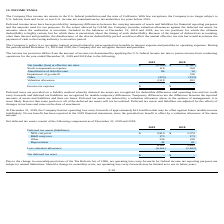According to Sunworks's financial document, What is the net operating loss carry-forwards at December 31, 2019? According to the financial document, $21.6 million. The relevant text states: "net operating loss carry-forwards of approximately $21.6 million that may be offset against future taxable income indefinitely. No tax benefit has been reported in t..." Also, What is the  NOL carryover for 2019? According to the financial document, $5,910. The relevant text states: "NOL carryover $ 5,910 $ 3,370..." Also, How are deferred tax assets and liabilities adjusted? adjusted for the effects of changes in tax laws and rates on the date of enactment. The document states: "realized. Deferred tax assets and liabilities are adjusted for the effects of changes in tax laws and rates on the date of enactment. At December 31, ..." Also, can you calculate: What is the percentage change in the total deferred tax assets from 2018 to 2019? To answer this question, I need to perform calculations using the financial data. The calculation is: (6,361-3,843)/3,843, which equals 65.52 (percentage). This is based on the information: "6,361 3,843 6,361 3,843..." The key data points involved are: 3,843, 6,361. Also, can you calculate: What is the percentage of R&D carryover in the total deferred tax assets in 2019? Based on the calculation: 173/6,361, the result is 2.72 (percentage). This is based on the information: "6,361 3,843 R&D carryover 173 173..." The key data points involved are: 173, 6,361. Also, can you calculate: What is the percentage of depreciation in the total deferred tax assets in 2018? Based on the calculation: 61/3,843, the result is 1.59 (percentage). This is based on the information: "6,361 3,843 6,361 3,843..." The key data points involved are: 3,843, 61. Additionally, In which year is the NOL carryover higher? According to the financial document, 2019. The relevant text states: "certain. Included in the balances at December 31, 2019 and 2018, are no tax positions for which the ultimate deductibility is highly certain, but for whic..." 